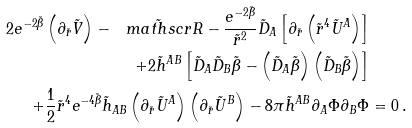Convert formula to latex. <formula><loc_0><loc_0><loc_500><loc_500>2 e ^ { - 2 \tilde { \beta } } \left ( \partial _ { \tilde { r } } \tilde { V } \right ) - \tilde { \ m a t h s c r { R } } - \frac { e ^ { - 2 \tilde { \beta } } } { \tilde { r } ^ { 2 } } \tilde { D } _ { A } \left [ \partial _ { \tilde { r } } \left ( \tilde { r } ^ { 4 } \tilde { U } ^ { A } \right ) \right ] & \\ + 2 \tilde { h } ^ { A B } \left [ \tilde { D } _ { A } \tilde { D } _ { B } \tilde { \beta } - \left ( \tilde { D } _ { A } \tilde { \beta } \right ) \left ( \tilde { D } _ { B } \tilde { \beta } \right ) \right ] & \\ + \frac { 1 } { 2 } \tilde { r } ^ { 4 } e ^ { - 4 \tilde { \beta } } \tilde { h } _ { A B } \left ( \partial _ { \tilde { r } } \tilde { U } ^ { A } \right ) \left ( \partial _ { \tilde { r } } \tilde { U } ^ { B } \right ) - 8 \pi \tilde { h } ^ { A B } \partial _ { A } \Phi \partial _ { B } \Phi & = 0 \, .</formula> 